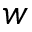<formula> <loc_0><loc_0><loc_500><loc_500>w</formula> 